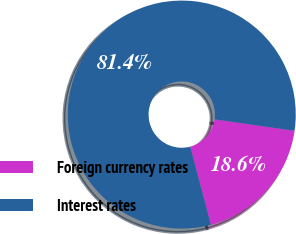<chart> <loc_0><loc_0><loc_500><loc_500><pie_chart><fcel>Foreign currency rates<fcel>Interest rates<nl><fcel>18.62%<fcel>81.38%<nl></chart> 